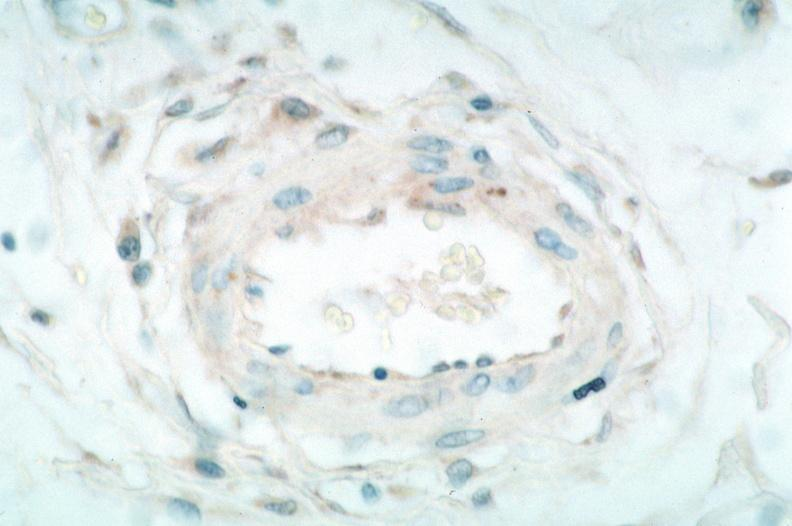does acid show vasculitis?
Answer the question using a single word or phrase. No 